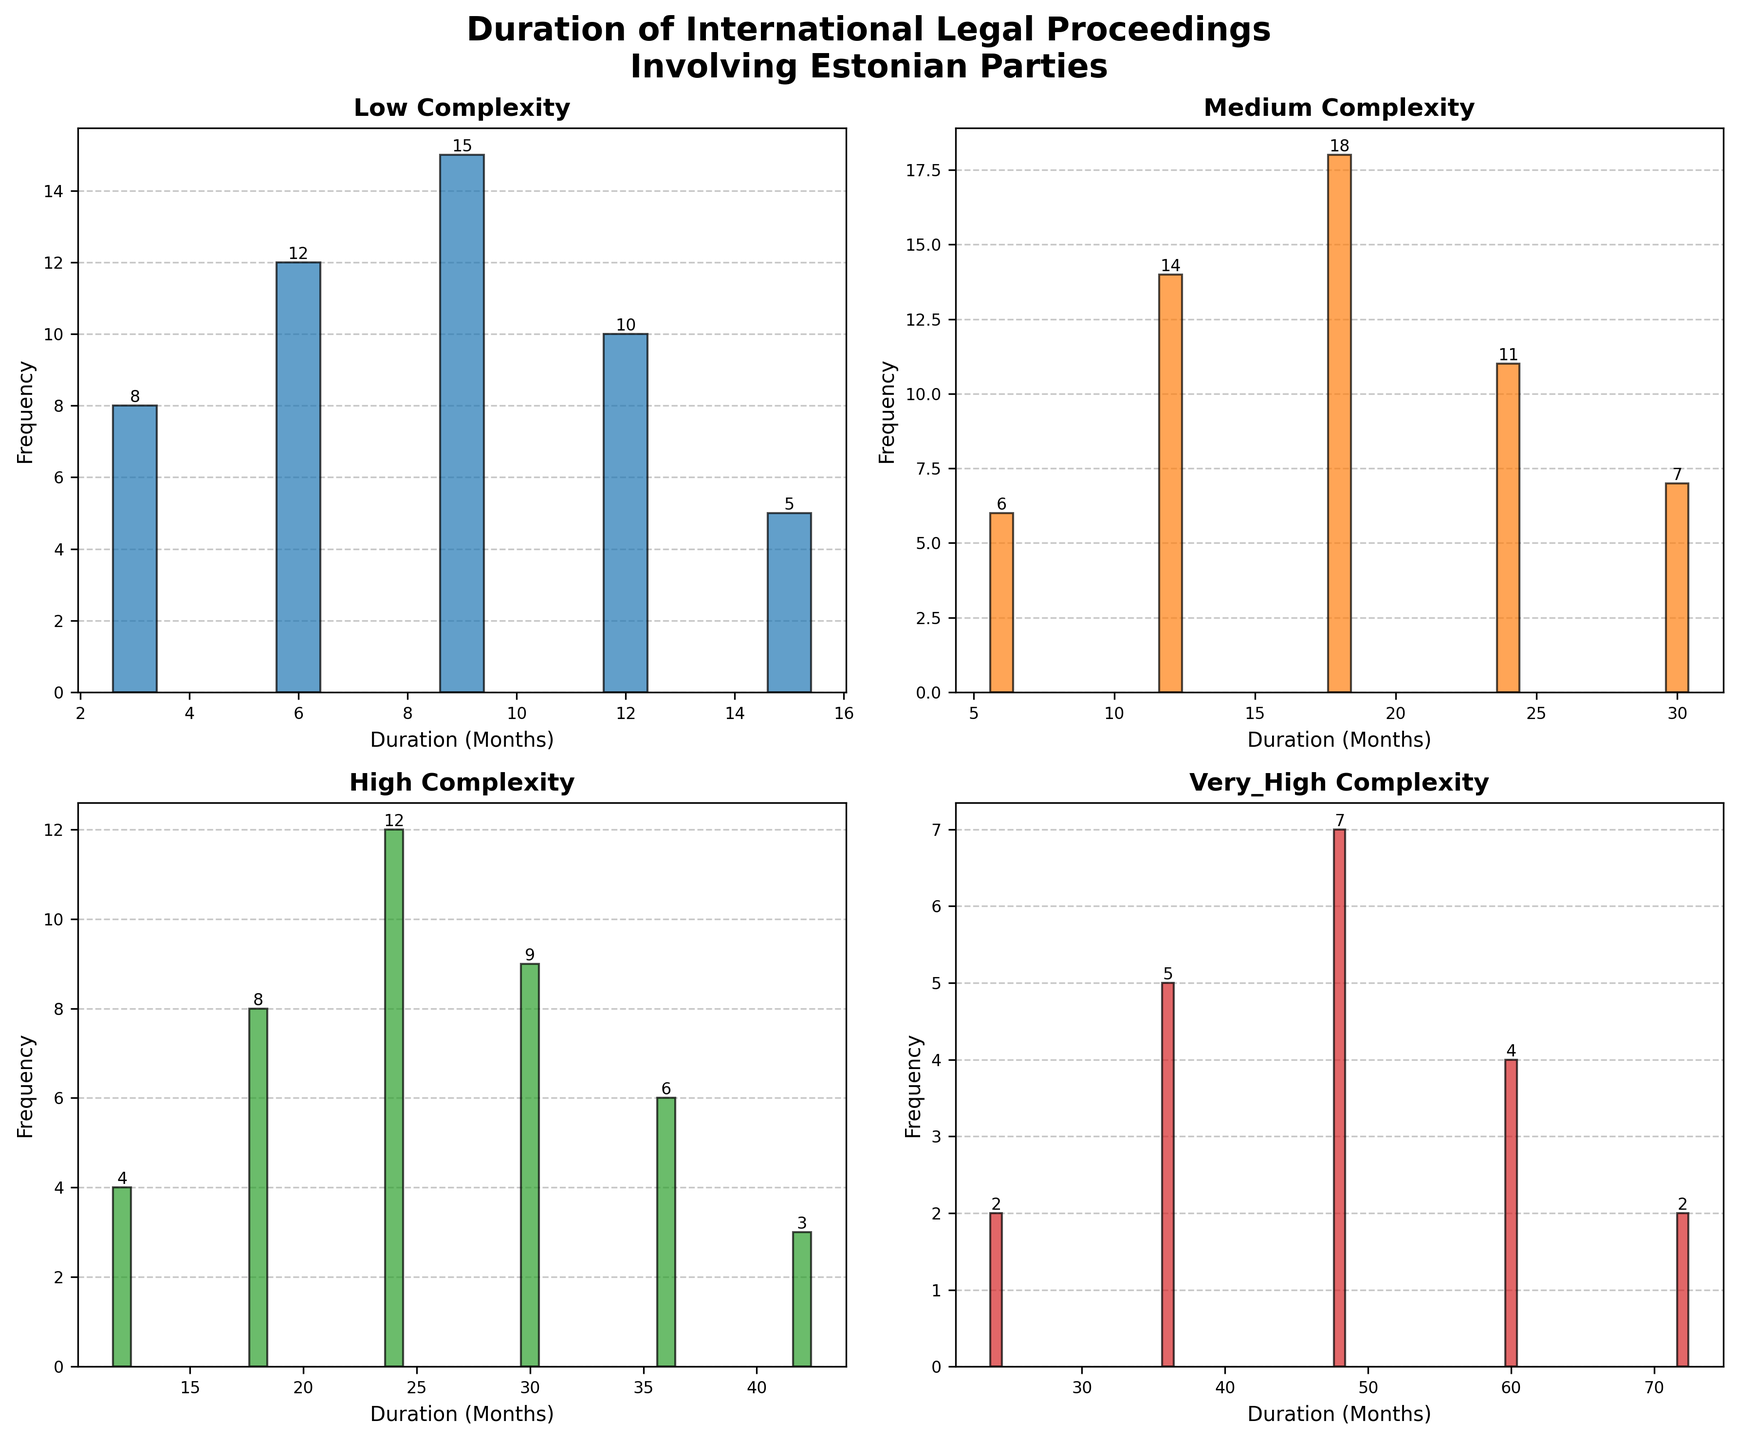What is the title of the figure? The title is located at the top of the figure. It is usually in a larger and bold font to stand out as the main title of the figure.
Answer: Duration of International Legal Proceedings Involving Estonian Parties How many subplots are there in the figure? The figure is divided into smaller sections, each representing a subplot. By counting these sections, you can determine the number of subplots.
Answer: 4 What is the color of the bars representing 'High' complexity cases? By visually examining the color of the bars in the subplot titled 'High Complexity,' you can identify the specific color used.
Answer: Green Which case complexity has the highest frequency at 18 months duration? Locate the subplots. In the 'Medium Complexity' subplot, identify the bar at 18 months and its frequency, comparing it to others if needed.
Answer: Medium What's the total number of legal proceedings with low complexity? Sum the frequencies of all bars in the 'Low Complexity' subplot. The heights of the bars represent their frequencies.
Answer: 50 What is the average duration for very high complexity cases? Identify the duration values for 'Very High Complexity' and their frequencies, multiply them, sum the results, then divide by the total frequency.
Answer: (24*2 + 36*5 + 48*7 + 60*4 + 72*2) / (2+5+7+4+2) = 48 Which complexity category shows the longest proceedings duration? Compare the xticks (duration values on the x-axis) of each subplot to find out which one spans the longest duration.
Answer: Very High How frequently do medium complexity cases last for 24 months? Find the bar labeled '24 months' within the 'Medium Complexity' subplot and read off the frequency value.
Answer: 11 In the 'High Complexity' category, what is the difference in frequency between the cases lasting 18 months and those lasting 42 months? Subtract the frequency of the bar at 42 months from the frequency of the bar at 18 months in the 'High Complexity' subplot.
Answer: 5 Comparing low and very high complexity cases, which has a higher frequency of cases lasting 12 months? Look at the frequency of the bar representing 12 months in both 'Low Complexity' and 'Very High Complexity' subplots, then compare.
Answer: Low 